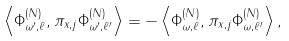Convert formula to latex. <formula><loc_0><loc_0><loc_500><loc_500>\left \langle \Phi _ { \omega ^ { \prime } , \ell } ^ { ( N ) } , \pi _ { x , j } \Phi _ { \omega ^ { \prime } , \ell ^ { \prime } } ^ { ( N ) } \right \rangle = - \left \langle \Phi _ { \omega , \ell } ^ { ( N ) } , \pi _ { x , j } \Phi _ { \omega , \ell ^ { \prime } } ^ { ( N ) } \right \rangle ,</formula> 